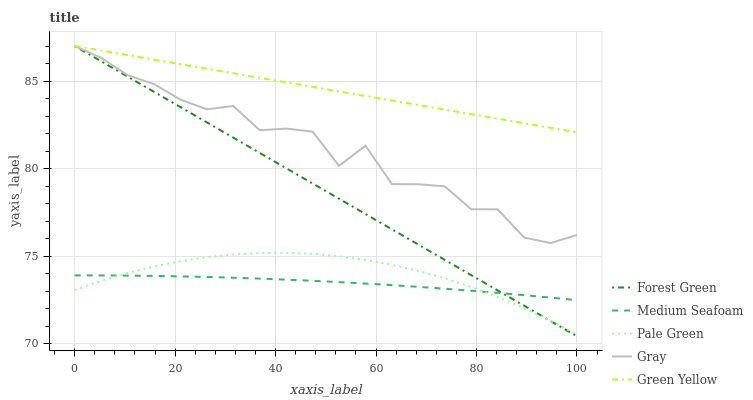Does Medium Seafoam have the minimum area under the curve?
Answer yes or no. Yes. Does Green Yellow have the maximum area under the curve?
Answer yes or no. Yes. Does Gray have the minimum area under the curve?
Answer yes or no. No. Does Gray have the maximum area under the curve?
Answer yes or no. No. Is Green Yellow the smoothest?
Answer yes or no. Yes. Is Gray the roughest?
Answer yes or no. Yes. Is Forest Green the smoothest?
Answer yes or no. No. Is Forest Green the roughest?
Answer yes or no. No. Does Gray have the lowest value?
Answer yes or no. No. Does Forest Green have the highest value?
Answer yes or no. Yes. Does Pale Green have the highest value?
Answer yes or no. No. Is Medium Seafoam less than Green Yellow?
Answer yes or no. Yes. Is Gray greater than Pale Green?
Answer yes or no. Yes. Does Pale Green intersect Forest Green?
Answer yes or no. Yes. Is Pale Green less than Forest Green?
Answer yes or no. No. Is Pale Green greater than Forest Green?
Answer yes or no. No. Does Medium Seafoam intersect Green Yellow?
Answer yes or no. No. 